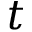Convert formula to latex. <formula><loc_0><loc_0><loc_500><loc_500>t</formula> 